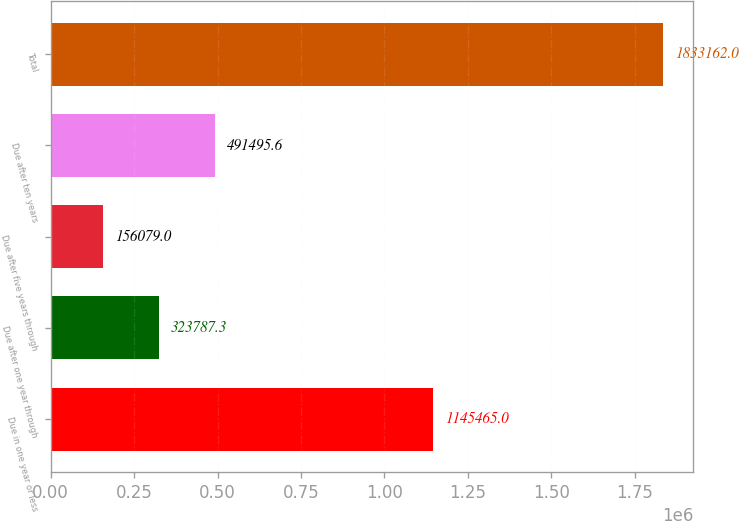Convert chart to OTSL. <chart><loc_0><loc_0><loc_500><loc_500><bar_chart><fcel>Due in one year or less<fcel>Due after one year through<fcel>Due after five years through<fcel>Due after ten years<fcel>Total<nl><fcel>1.14546e+06<fcel>323787<fcel>156079<fcel>491496<fcel>1.83316e+06<nl></chart> 